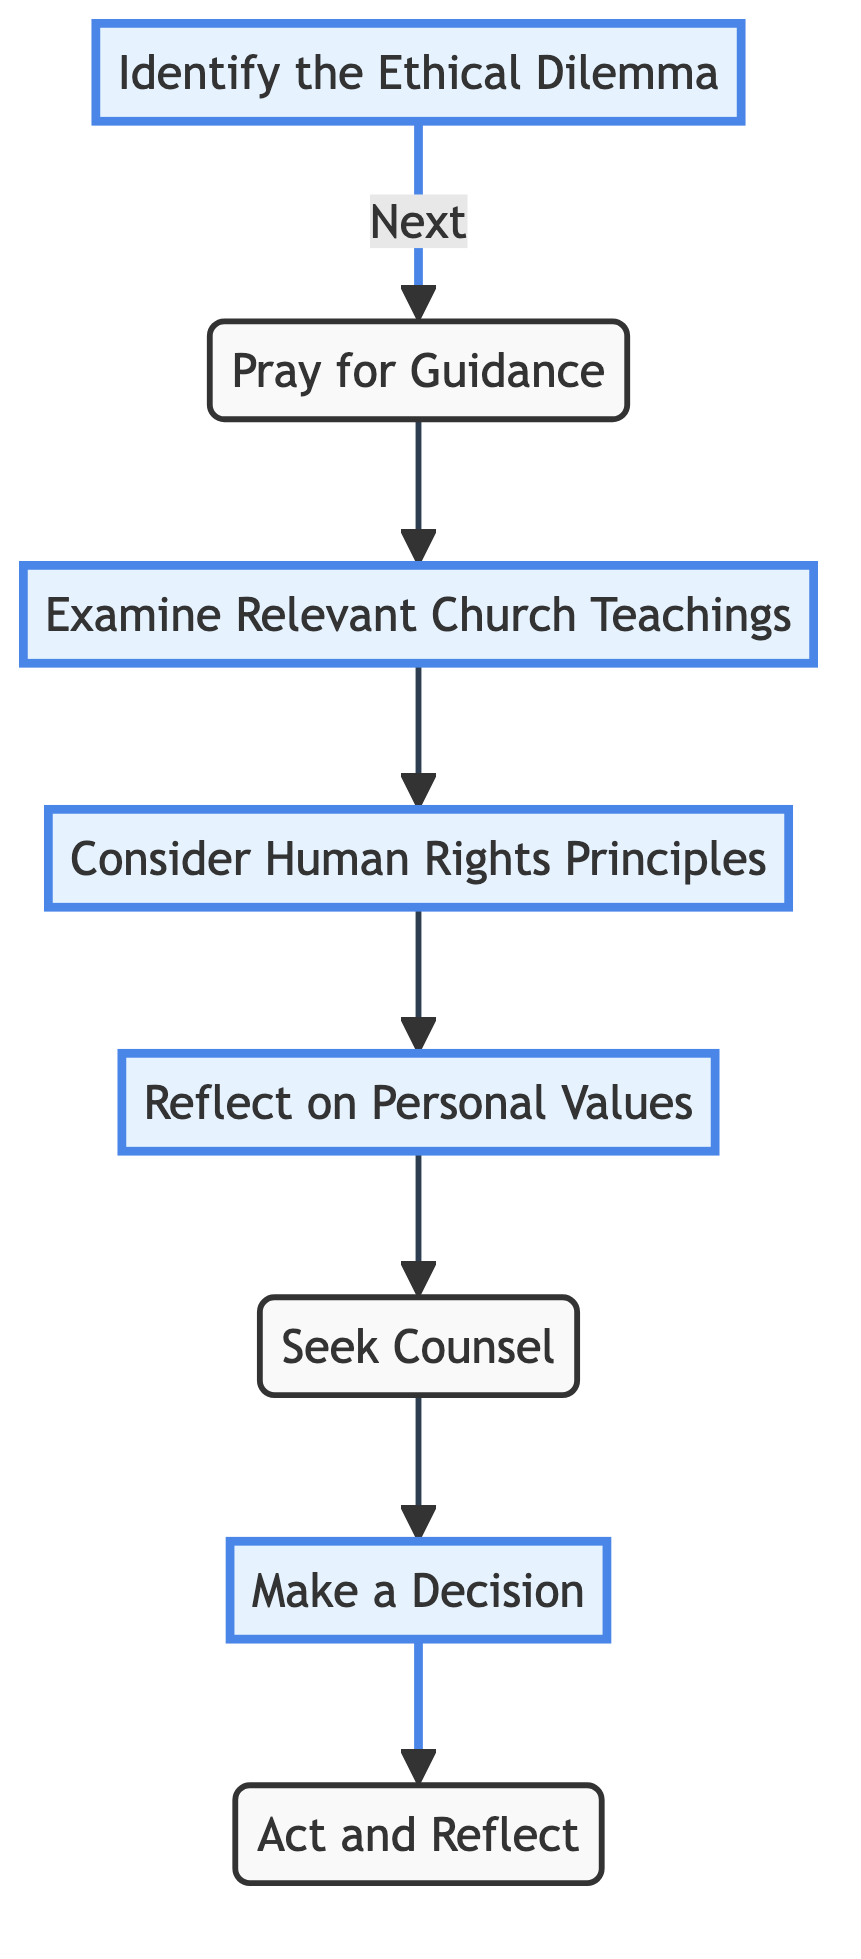What is the first step in the decision-making process? The first step in the diagram is labeled as "Identify the Ethical Dilemma," which is the starting point of the decision-making process.
Answer: Identify the Ethical Dilemma How many steps are there in the decision-making process? By counting the nodes in the diagram, there are a total of eight distinct steps presented, indicating the entire flow of the decision-making process.
Answer: Eight What is the connection between "Pray for Guidance" and "Examine Relevant Church Teachings"? In the flow chart, an arrow points directly from "Pray for Guidance" to "Examine Relevant Church Teachings," indicating that after praying, the next step is to examine teachings.
Answer: Examine Relevant Church Teachings Which step involves discussing the dilemma with a trusted individual? The step that involves discussing the ethical dilemma is "Seek Counsel," where one is encouraged to consult with a priest or spiritual advisor.
Answer: Seek Counsel What do you do after making a decision? After "Make a Decision," the next step indicated by the diagram is to "Act and Reflect," which means to implement the decision and then consider the outcomes.
Answer: Act and Reflect What are the last two steps in the flowchart? The last two steps, as seen in the flowchart, are "Make a Decision" followed by "Act and Reflect," showing the concluding actions in the ethical decision-making process.
Answer: Make a Decision, Act and Reflect Describe the role of "Consider Human Rights Principles" in the process. This step serves to evaluate the ethical dilemma through the lens of human rights ideals such as dignity and justice, ensuring the decision respects these principles.
Answer: Evaluate the dilemma in light of human rights principles Which step emphasizes personal beliefs and values? "Reflect on Personal Values" is the step that specifically focuses on assessing one’s own beliefs and how they align with faith and human rights.
Answer: Reflect on Personal Values 